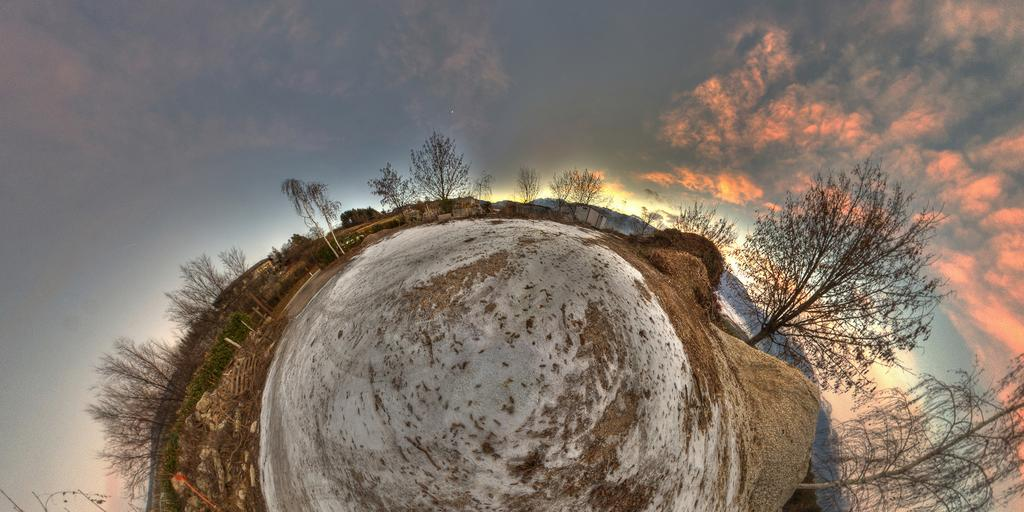What is the perspective of the image? The image shows a top view of the ground. What type of vegetation can be seen around the ground? Dry trees are present around the ground. What is visible in the background of the image? The sky is visible in the image. What can be observed in the sky? Clouds are present in the sky. How many bags of popcorn are visible on the ground in the image? There are no bags of popcorn present in the image. Is there a bike visible on the ground in the image? There is no bike visible on the ground in the image. 